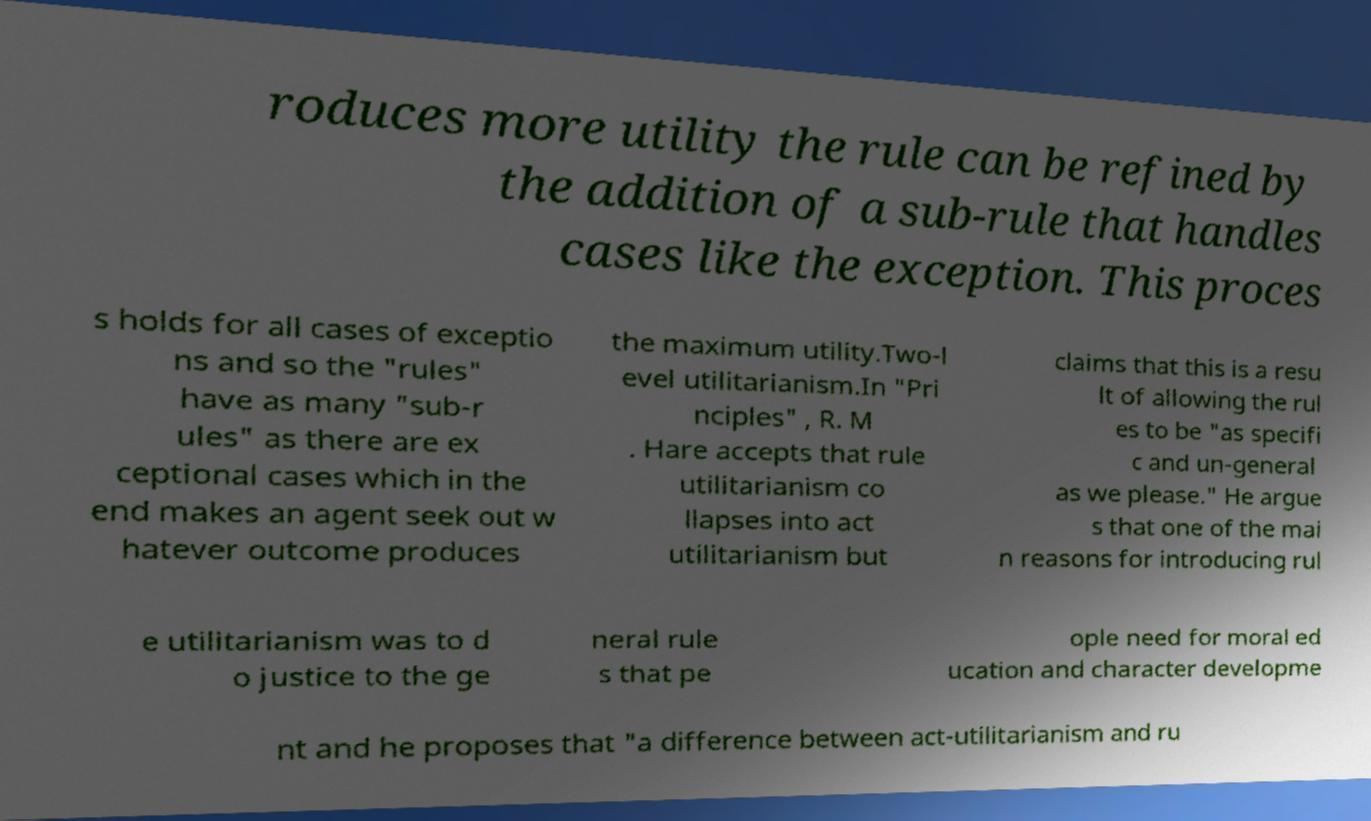Could you assist in decoding the text presented in this image and type it out clearly? roduces more utility the rule can be refined by the addition of a sub-rule that handles cases like the exception. This proces s holds for all cases of exceptio ns and so the "rules" have as many "sub-r ules" as there are ex ceptional cases which in the end makes an agent seek out w hatever outcome produces the maximum utility.Two-l evel utilitarianism.In "Pri nciples" , R. M . Hare accepts that rule utilitarianism co llapses into act utilitarianism but claims that this is a resu lt of allowing the rul es to be "as specifi c and un-general as we please." He argue s that one of the mai n reasons for introducing rul e utilitarianism was to d o justice to the ge neral rule s that pe ople need for moral ed ucation and character developme nt and he proposes that "a difference between act-utilitarianism and ru 